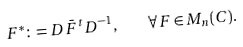<formula> <loc_0><loc_0><loc_500><loc_500>F ^ { * } \colon = D \bar { F } ^ { t } D ^ { - 1 } , \quad \forall F \in M _ { n } ( C ) .</formula> 